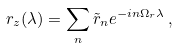Convert formula to latex. <formula><loc_0><loc_0><loc_500><loc_500>r _ { z } ( \lambda ) = \sum _ { n } \tilde { r } _ { n } e ^ { - i n \Omega _ { r } \lambda } \, ,</formula> 